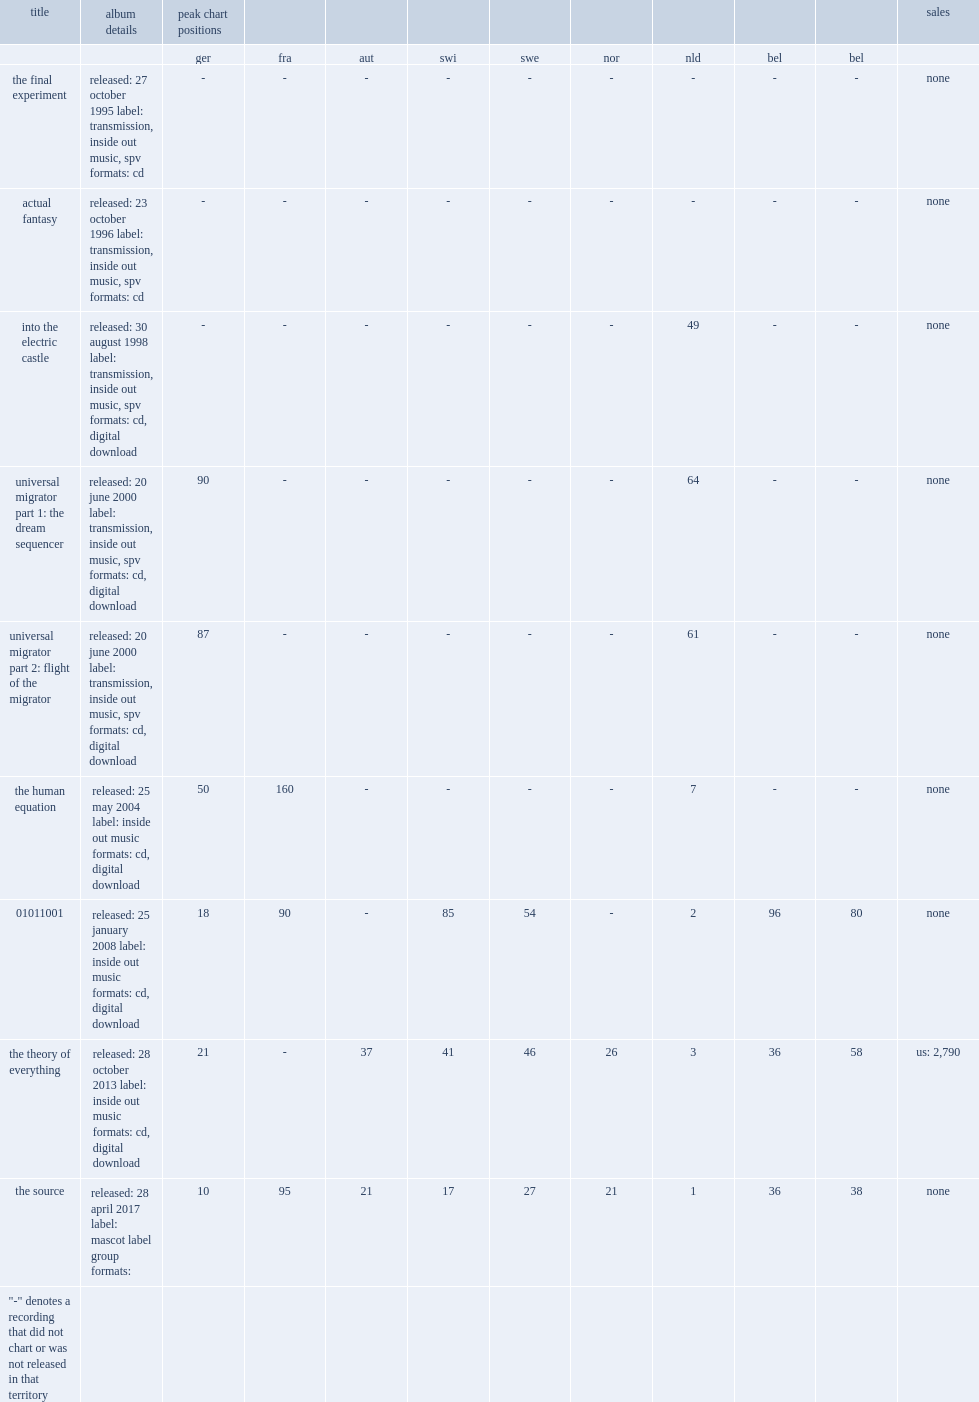When was arjen's album 01011001 released? Released: 25 january 2008 label: inside out music formats: cd, digital download. 